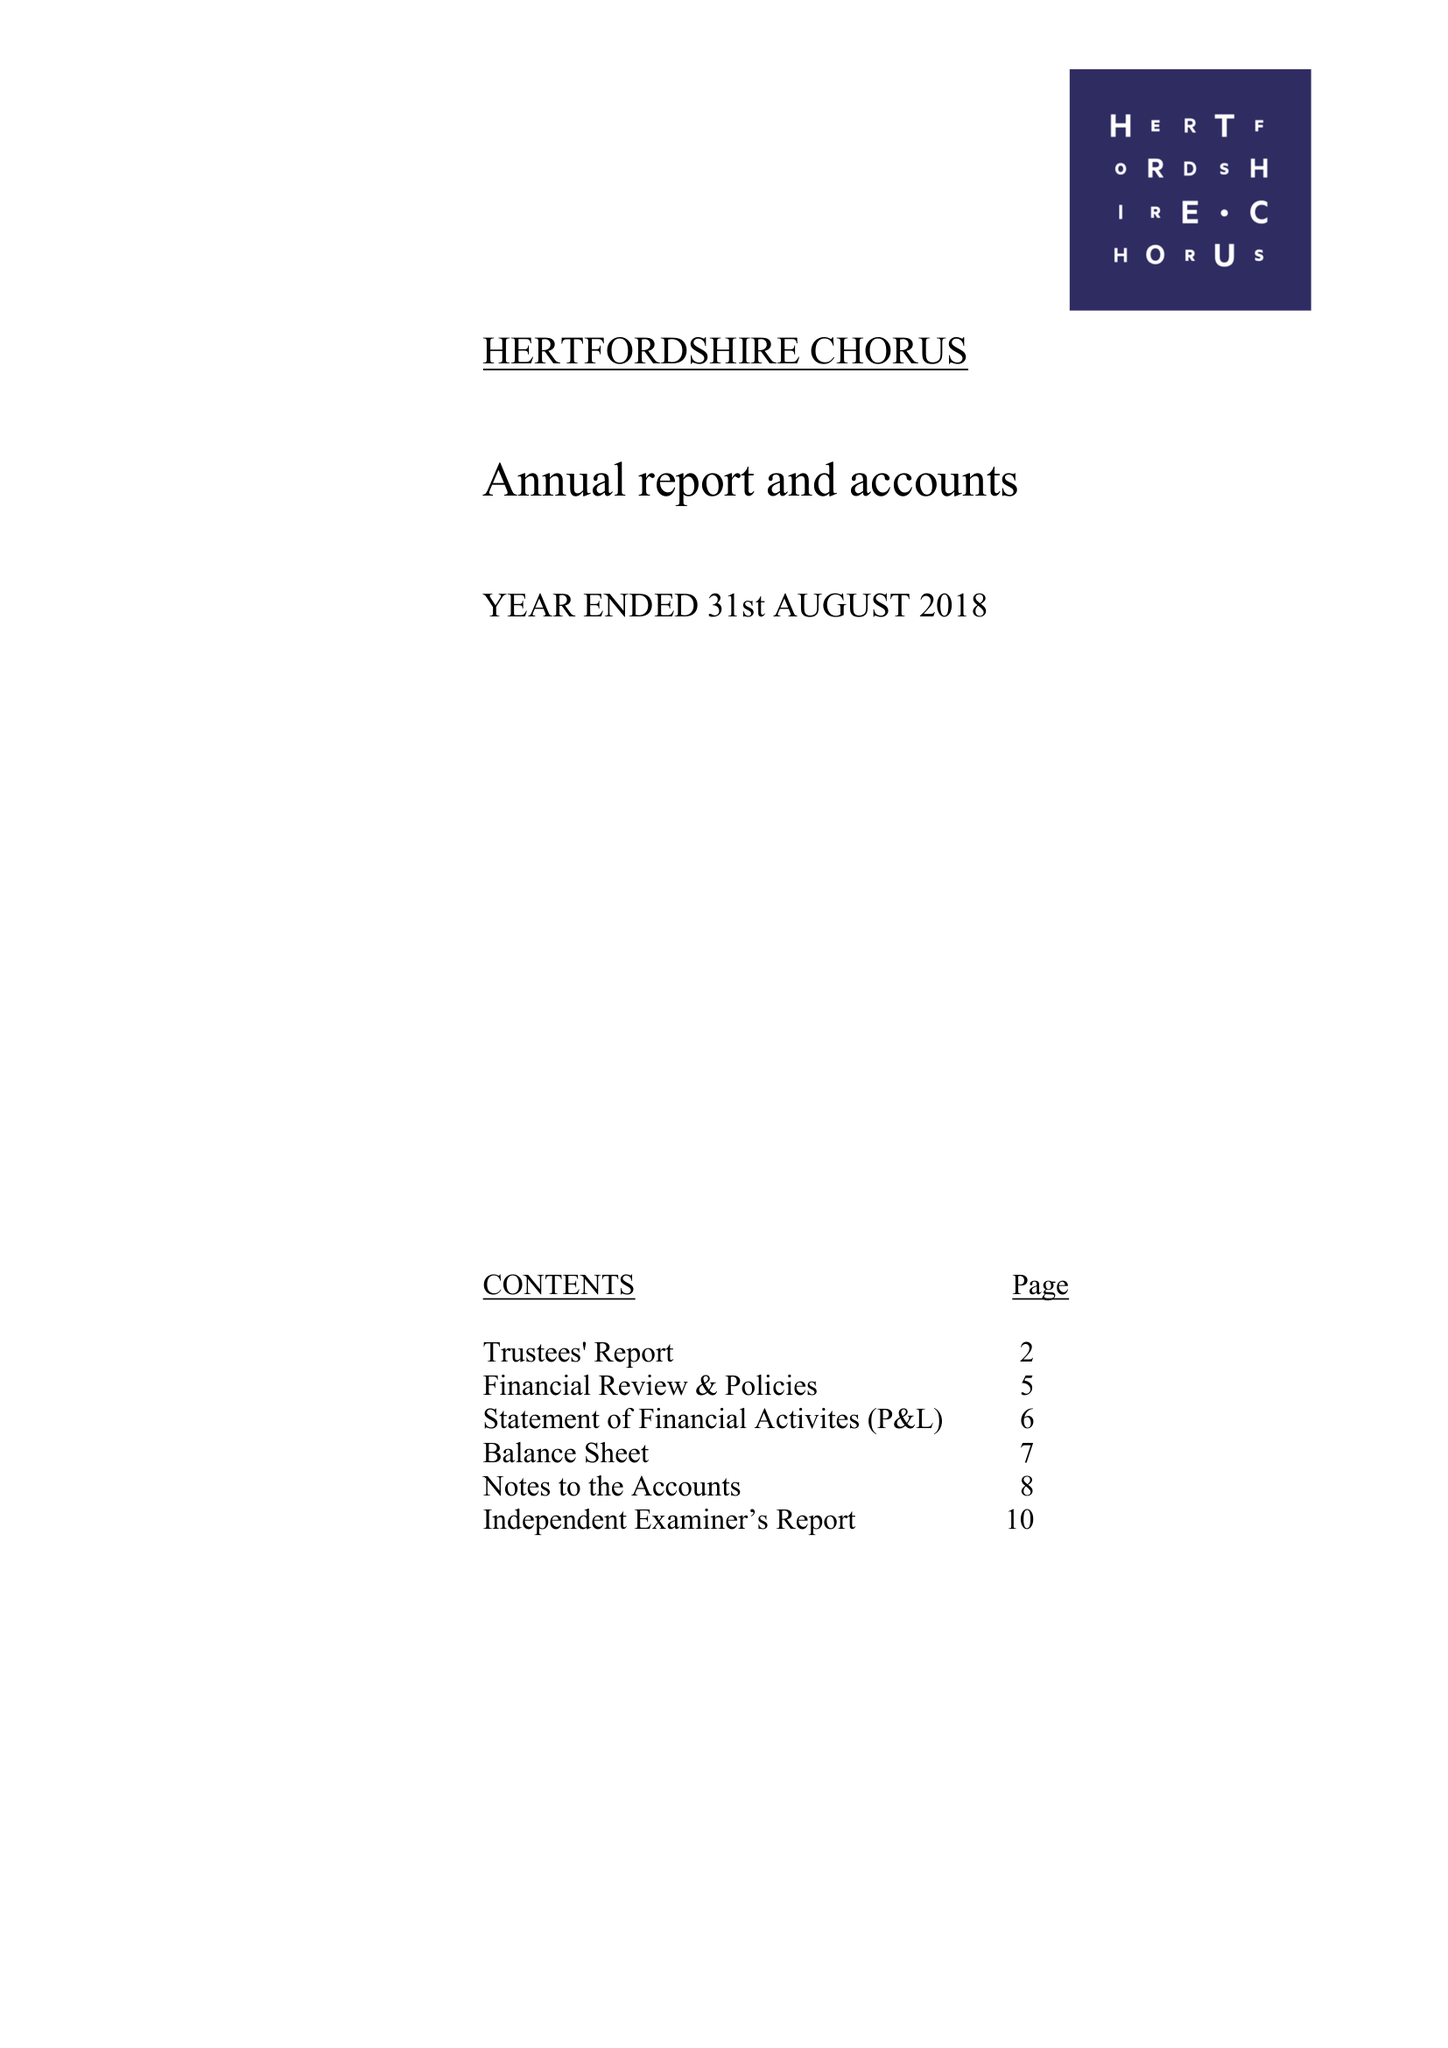What is the value for the address__postcode?
Answer the question using a single word or phrase. AL1 5QZ 